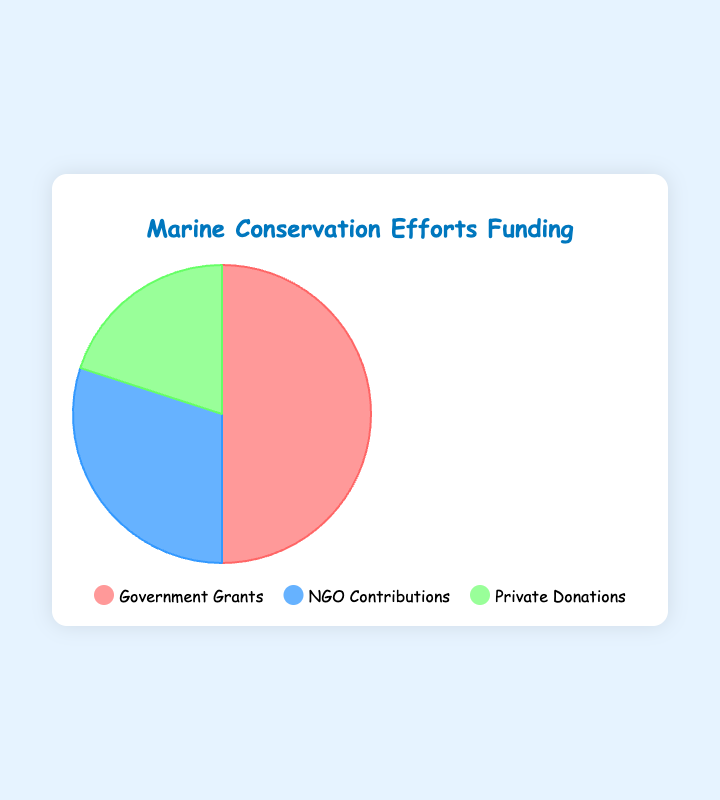What is the largest source of funding for marine conservation efforts? By looking at the pie chart, we can see that the largest segment is labeled "Government Grants". This corresponds to the largest funding amount.
Answer: Government Grants What percentage of the total funding comes from NGO Contributions? The pie chart allows us to calculate the percentage from the total funding. NGO Contributions are $3,000,000 out of a total $10,000,000. The calculation is 3000000 / 10000000 = 0.3, which is 30%.
Answer: 30% How much more funding does the Government provide compared to Private Donations? The pie chart shows that Government Grants amount to $5,000,000, and Private Donations are $2,000,000. The difference is 5000000 - 2000000 = $3,000,000.
Answer: $3,000,000 What is the total amount of funding for marine conservation efforts? By summing all the amounts indicated in the chart: $5,000,000 (Government Grants) + $3,000,000 (NGO Contributions) + $2,000,000 (Private Donations) = $10,000,000.
Answer: $10,000,000 If Private Donations were to double, what fraction of the total funding would they represent? If Private Donations double, the amount would be $4,000,000. The new total funding would be $5,000,000 (Government Grants) + $3,000,000 (NGO Contributions) + $4,000,000 (Private Donations) = $12,000,000. The fraction for Private Donations would be 4000000 / 12000000 = 1/3.
Answer: 1/3 Which funding source has the smallest share visually on the pie chart? By looking at the pie chart, the smallest segment corresponds to Private Donations.
Answer: Private Donations What is the combined funding amount from non-governmental sources? NGO Contributions and Private Donations are non-governmental sources. Sum their amounts: $3,000,000 (NGO Contributions) + $2,000,000 (Private Donations) = $5,000,000.
Answer: $5,000,000 Which funding segment is represented by the color blue in the pie chart? The legend indicates that "NGO Contributions" are shown in blue.
Answer: NGO Contributions 